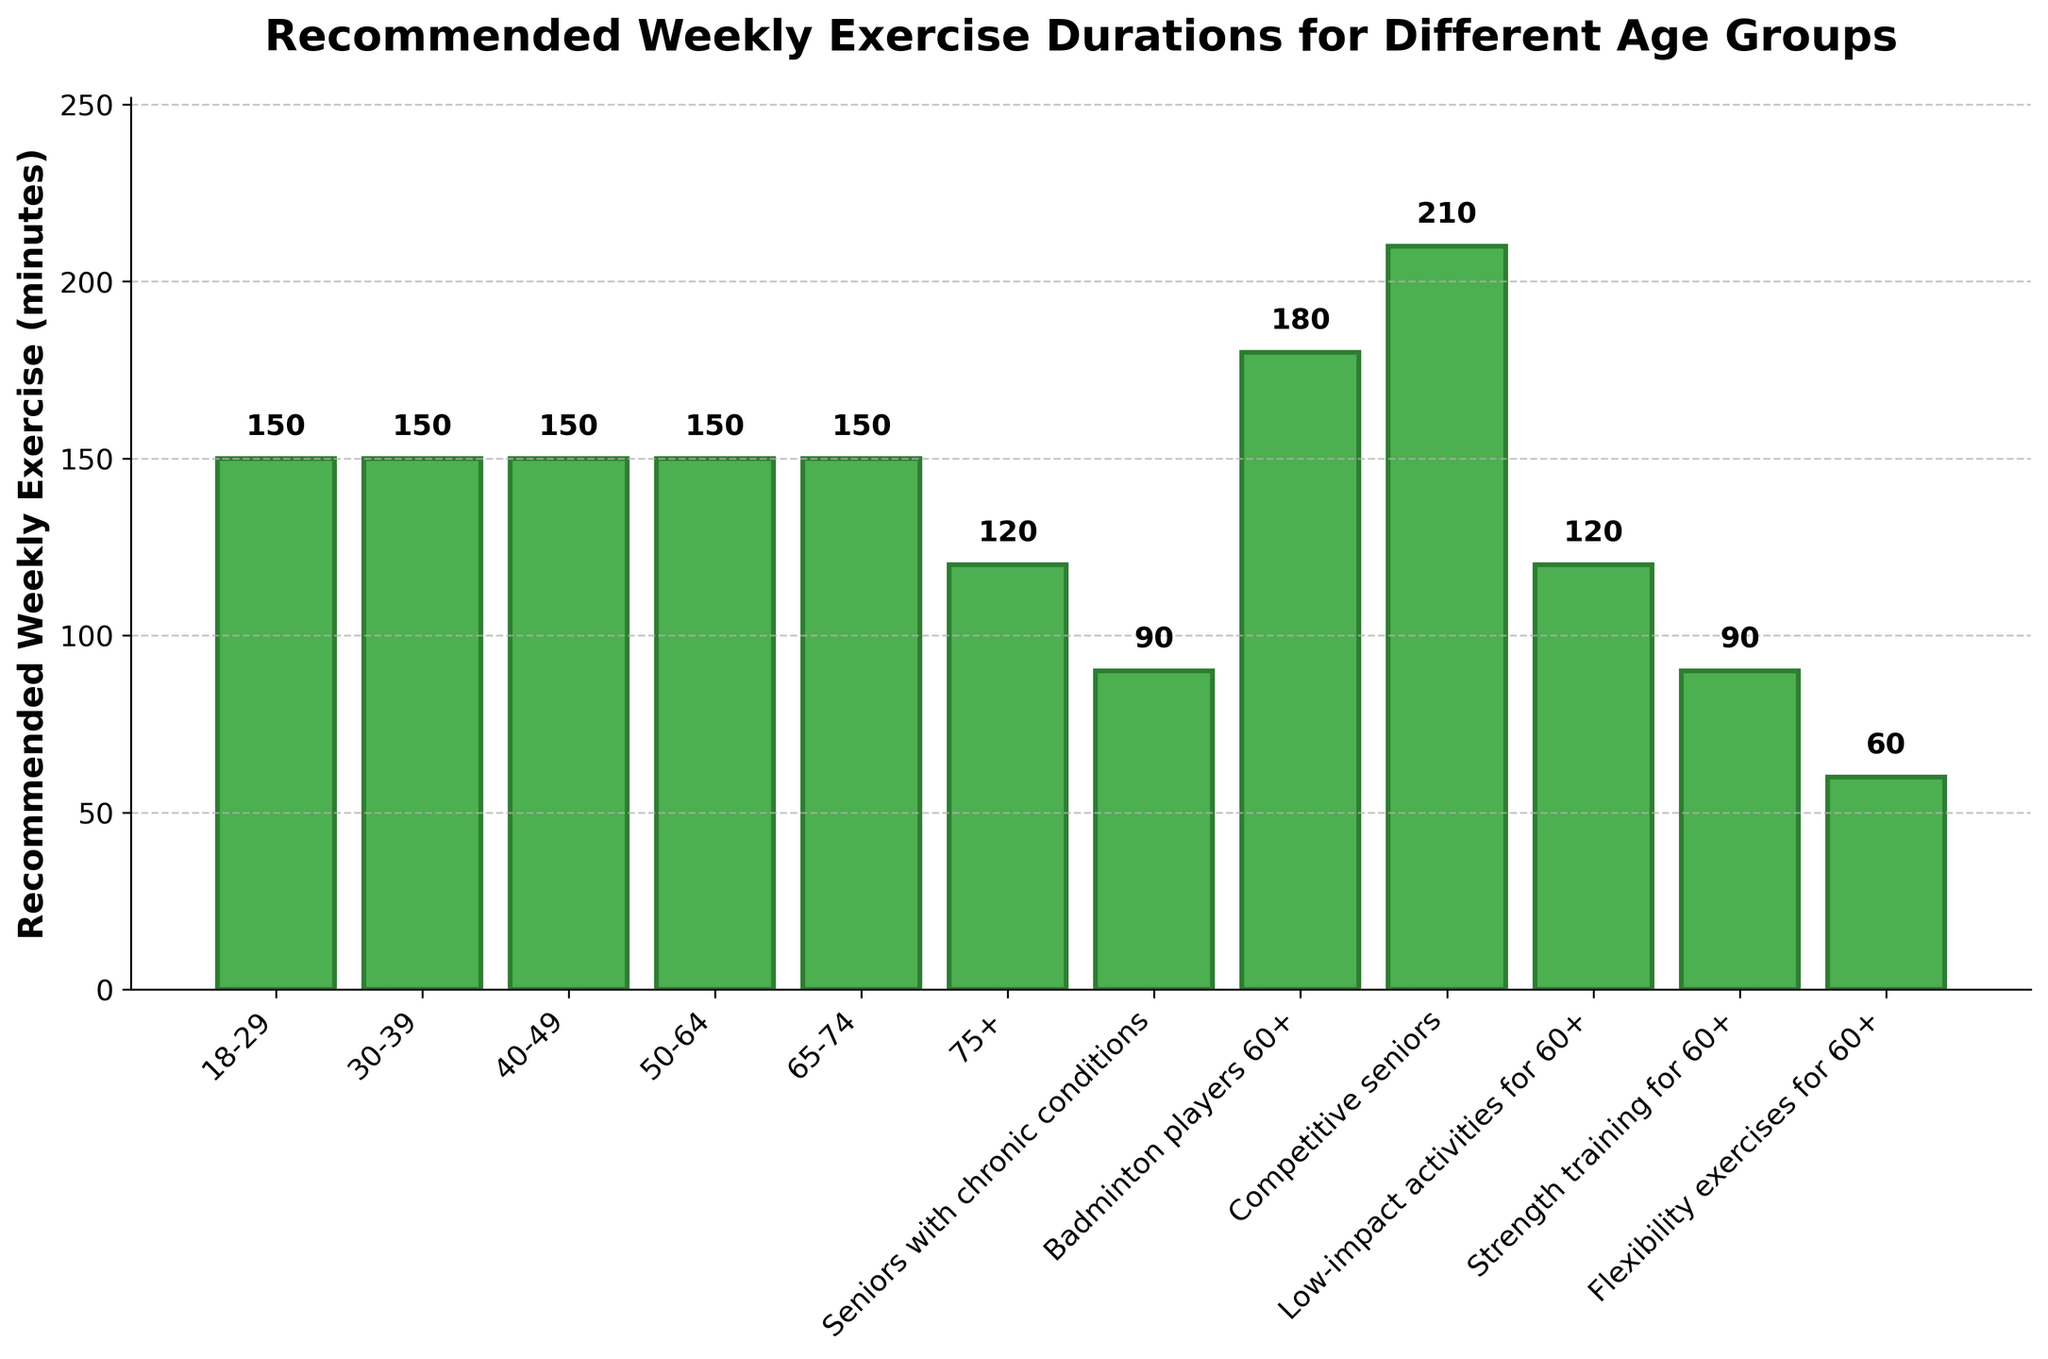What's the highest recommended weekly exercise duration among the listed groups? Look for the tallest bar in the chart, which represents the highest recommended weekly exercise duration. It corresponds to "Competitive seniors" with a value of 210 minutes.
Answer: 210 minutes How much more exercise is recommended for "Competitive seniors" compared to "Seniors with chronic conditions"? Identify the values for "Competitive seniors" (210 minutes) and "Seniors with chronic conditions" (90 minutes). Subtract the latter from the former: 210 - 90 = 120 minutes.
Answer: 120 minutes Which group has the lowest recommended weekly exercise duration? Look for the shortest bar in the chart, which represents the lowest recommended weekly exercise duration. It corresponds to "Flexibility exercises for 60+" with a value of 60 minutes.
Answer: Flexibility exercises for 60+ What is the average recommended exercise duration for the age groups 18-29, 30-39, 40-49, 50-64, and 65-74? Sum the values for these age groups: 150 + 150 + 150 + 150 + 150 = 750. Divide by the number of age groups (5): 750 / 5 = 150.
Answer: 150 minutes Is the recommended duration of "Badminton players 60+" greater than that of "Low-impact activities for 60+"? Compare the values for "Badminton players 60+" (180 minutes) and "Low-impact activities for 60+" (120 minutes). Since 180 > 120, the answer is yes.
Answer: Yes Which two age groups have the same recommended weekly exercise duration? Look for bars with the same height. "18-29", "30-39", "40-49", "50-64", and "65-74" all have the same recommended weekly exercise duration of 150 minutes.
Answer: 18-29 and 30-39 (note: others also share 150 minutes) What is the total recommended weekly exercise duration for all groups specifically mentioned for those aged 60+? Sum the values for "Badminton players 60+" (180), "Competitive seniors" (210), "Low-impact activities for 60+" (120), "Strength training for 60+" (90), and "Flexibility exercises for 60+" (60). Total: 180 + 210 + 120 + 90 + 60 = 660 minutes.
Answer: 660 minutes For the standard age group 65-74, what percentage of "Competitive seniors" recommended exercise is it? The recommended duration for 65-74 is 150 minutes, and for "Competitive seniors" it is 210 minutes. Calculate (150 / 210) * 100 to get the percentage: (150 / 210) * 100 ≈ 71.43%.
Answer: Approximately 71.43% By how much does the exercise duration for "Competitive seniors" exceed that of "Low-impact activities for 60+"? Subtract the recommended duration of "Low-impact activities for 60+" (120 minutes) from that of "Competitive seniors" (210 minutes): 210 - 120 = 90 minutes.
Answer: 90 minutes What's the difference in recommended weekly exercise duration between "18-29" and "75+" age groups? Subtract the duration for "75+" (120 minutes) from that of "18-29" (150 minutes): 150 - 120 = 30 minutes.
Answer: 30 minutes 